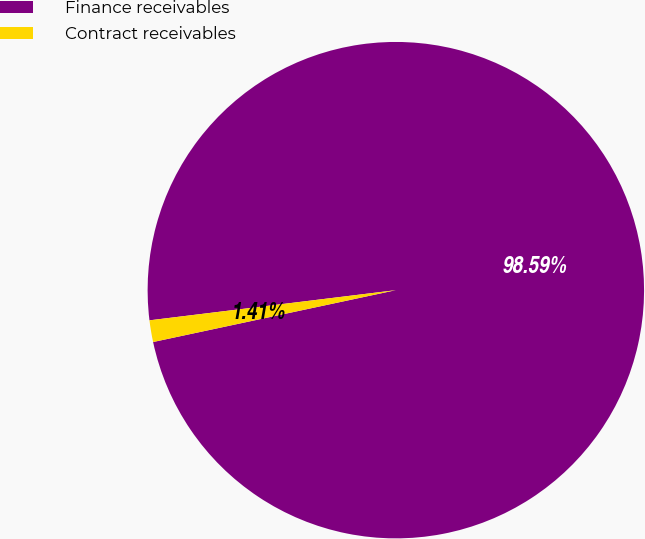Convert chart to OTSL. <chart><loc_0><loc_0><loc_500><loc_500><pie_chart><fcel>Finance receivables<fcel>Contract receivables<nl><fcel>98.59%<fcel>1.41%<nl></chart> 